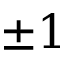<formula> <loc_0><loc_0><loc_500><loc_500>\pm 1</formula> 